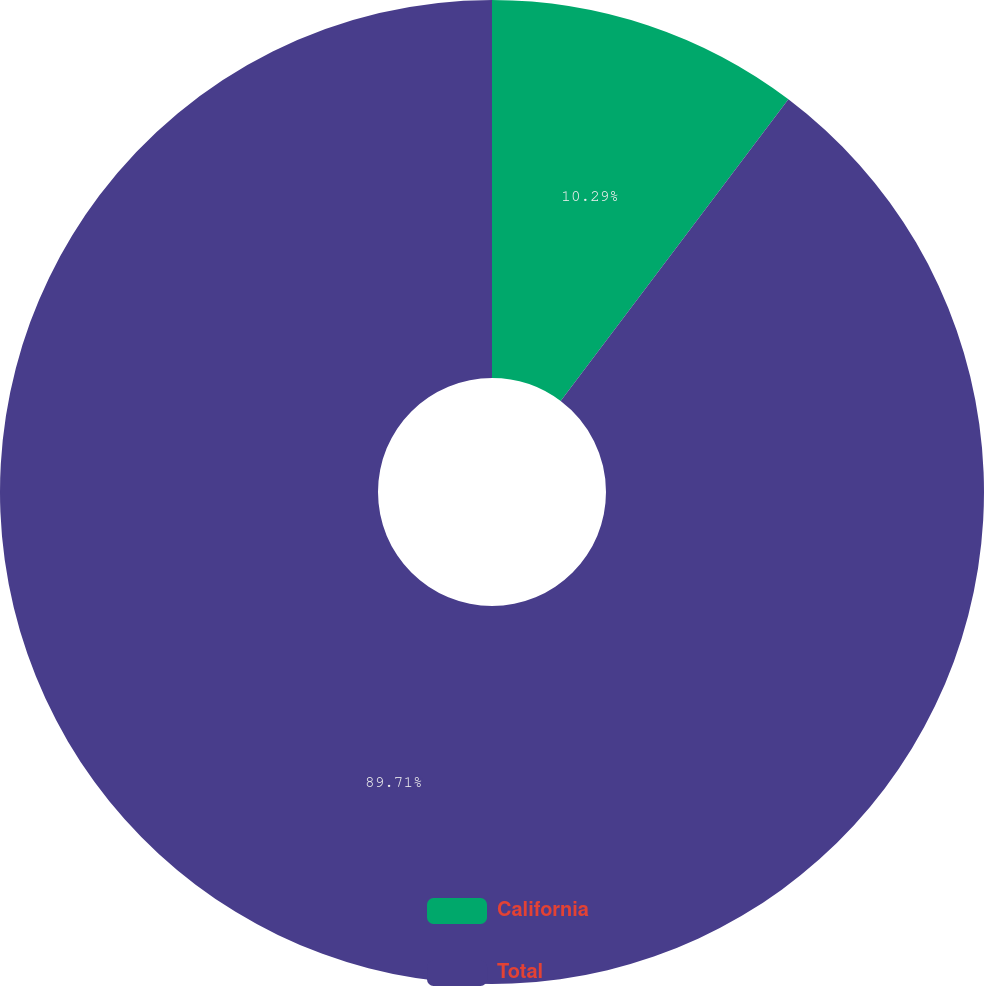Convert chart to OTSL. <chart><loc_0><loc_0><loc_500><loc_500><pie_chart><fcel>California<fcel>Total<nl><fcel>10.29%<fcel>89.71%<nl></chart> 